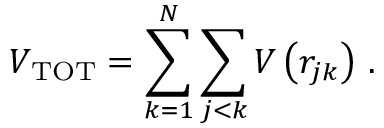Convert formula to latex. <formula><loc_0><loc_0><loc_500><loc_500>V _ { T O T } = \sum _ { k = 1 } ^ { N } \sum _ { j < k } V \left ( r _ { j k } \right ) \, .</formula> 